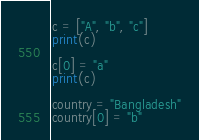Convert code to text. <code><loc_0><loc_0><loc_500><loc_500><_Python_>c = ["A", "b", "c"]
print(c)

c[0] = "a"
print(c)

country = "Bangladesh"
country[0] = "b"
</code> 